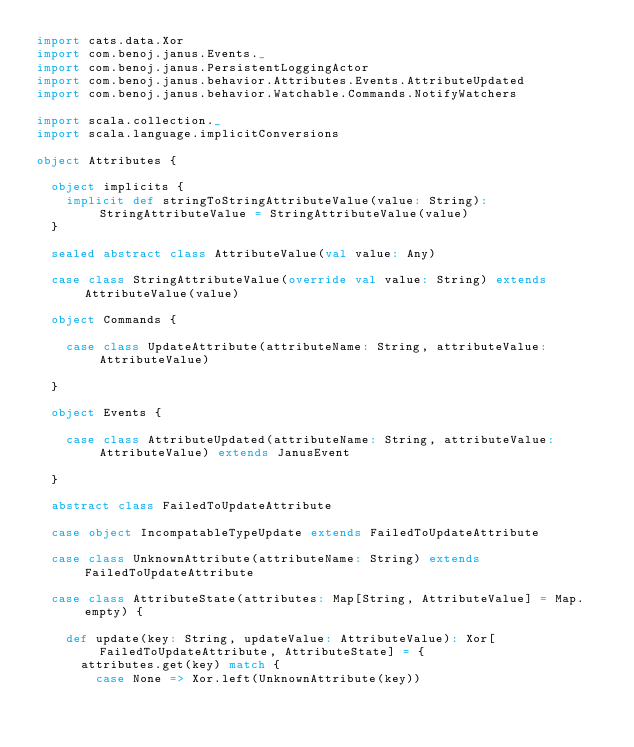<code> <loc_0><loc_0><loc_500><loc_500><_Scala_>import cats.data.Xor
import com.benoj.janus.Events._
import com.benoj.janus.PersistentLoggingActor
import com.benoj.janus.behavior.Attributes.Events.AttributeUpdated
import com.benoj.janus.behavior.Watchable.Commands.NotifyWatchers

import scala.collection._
import scala.language.implicitConversions

object Attributes {

  object implicits {
    implicit def stringToStringAttributeValue(value: String): StringAttributeValue = StringAttributeValue(value)
  }

  sealed abstract class AttributeValue(val value: Any)

  case class StringAttributeValue(override val value: String) extends AttributeValue(value)

  object Commands {

    case class UpdateAttribute(attributeName: String, attributeValue: AttributeValue)

  }

  object Events {

    case class AttributeUpdated(attributeName: String, attributeValue: AttributeValue) extends JanusEvent

  }

  abstract class FailedToUpdateAttribute

  case object IncompatableTypeUpdate extends FailedToUpdateAttribute

  case class UnknownAttribute(attributeName: String) extends FailedToUpdateAttribute

  case class AttributeState(attributes: Map[String, AttributeValue] = Map.empty) {

    def update(key: String, updateValue: AttributeValue): Xor[FailedToUpdateAttribute, AttributeState] = {
      attributes.get(key) match {
        case None => Xor.left(UnknownAttribute(key))</code> 